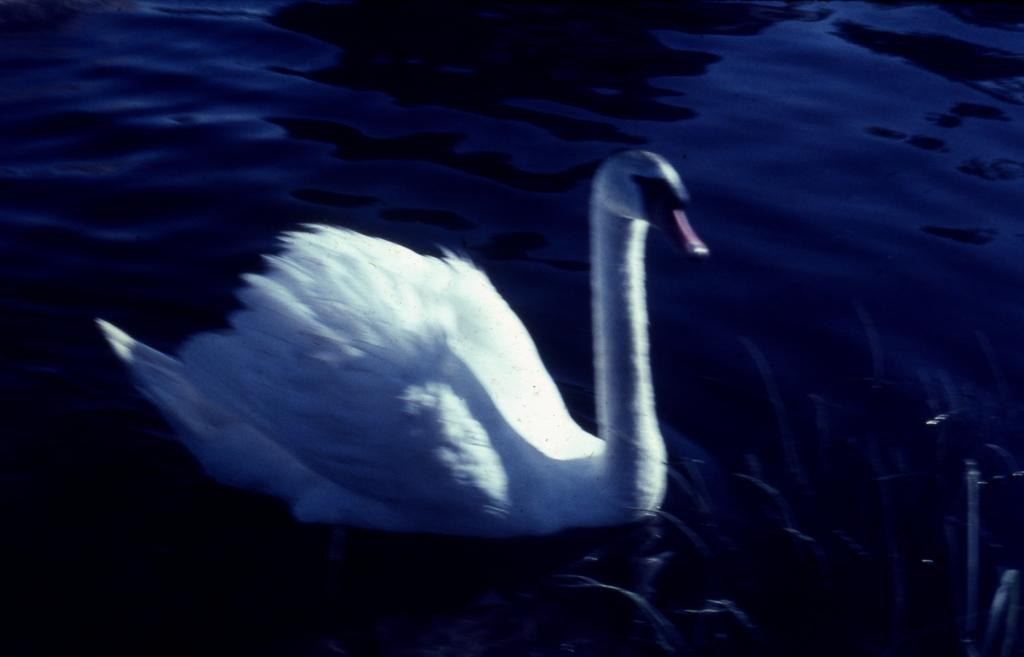What type of animal is in the image? There is a swan in the image. What color is the swan? The swan is white in color. What is visible at the bottom of the image? There is water visible at the bottom of the image. How many team members are visible in the image? There is no reference to a team or team members in the image, so it's not possible to answer that question. What is the fifth item in the image? There is no indication of a list of items in the image, so it's not possible to determine the fifth item. 